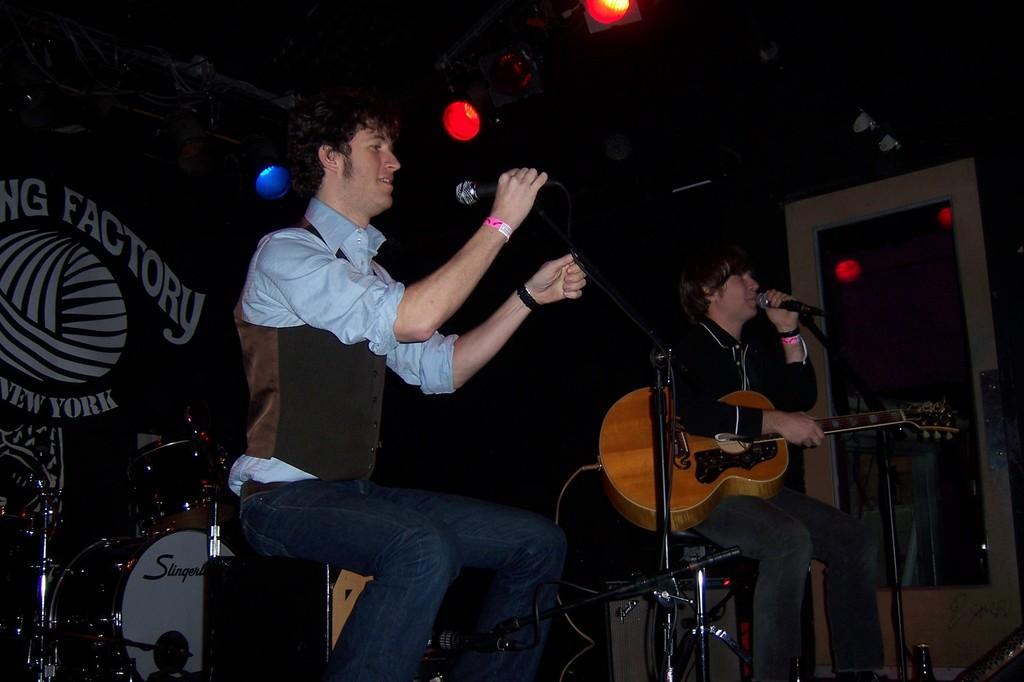Describe this image in one or two sentences. In this image, few peoples are playing a musical instrument. The middle person is holding a microphone and he sat on a stool. at the background, we can see banner, lights, glass door. 